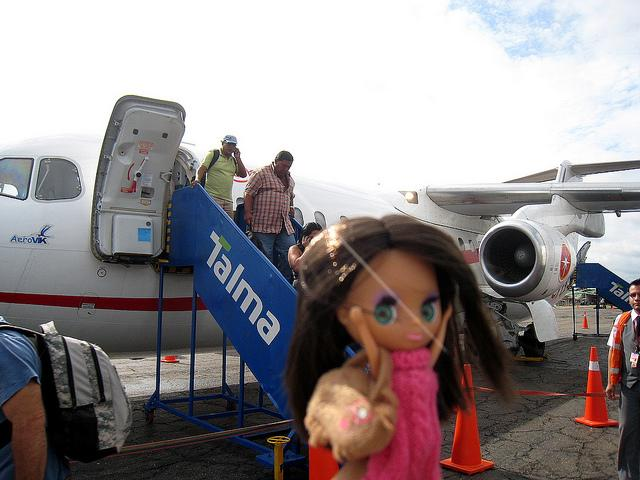What type of doll is in the front of the picture?

Choices:
A) barbie
B) beanie babies
C) bratz
D) elsa bratz 